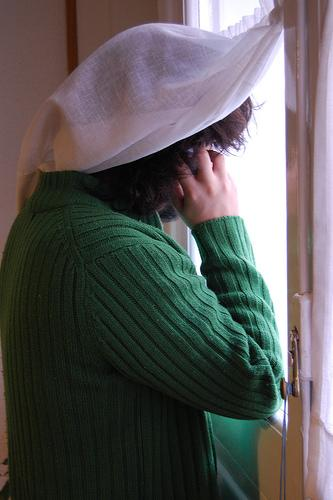Using given information, create a scene about the person in the image. A long-haired man wearing a green sweater is standing by a window, talking on the phone, and peering out under white curtains. Mention any two objects of different colors found in the image. A white curtain on the window and a green part on the wall. Combine the information about the person's sweater and the wall in the image. The person in the image is wearing a green sweater which casts a green shadow on the wall. Identify the action of the person in the image and describe the object they are interacting with. The person is looking out the window holding a phone to their ear. Describe one metallic object and one non-metallic object in the image. The doorknob is metallic and the elbow of a man is non-metallic. Mention any two objects tied to each other in the image. A blue ribbon is tied to the knob. What is the color of the curtain, and where does it appear? The curtain is white and appears above the man's head. Describe the person's hair and any other facial feature mentioned in the image. The person has dark hair and a black beard. What color is the person's sweater, and describe its appearance on the wall. The sweater is green, and its shadow can be seen on the wall. Identify two objects related to the window and provide their colors. White curtains are on the windows and a handle on the window is metal. 